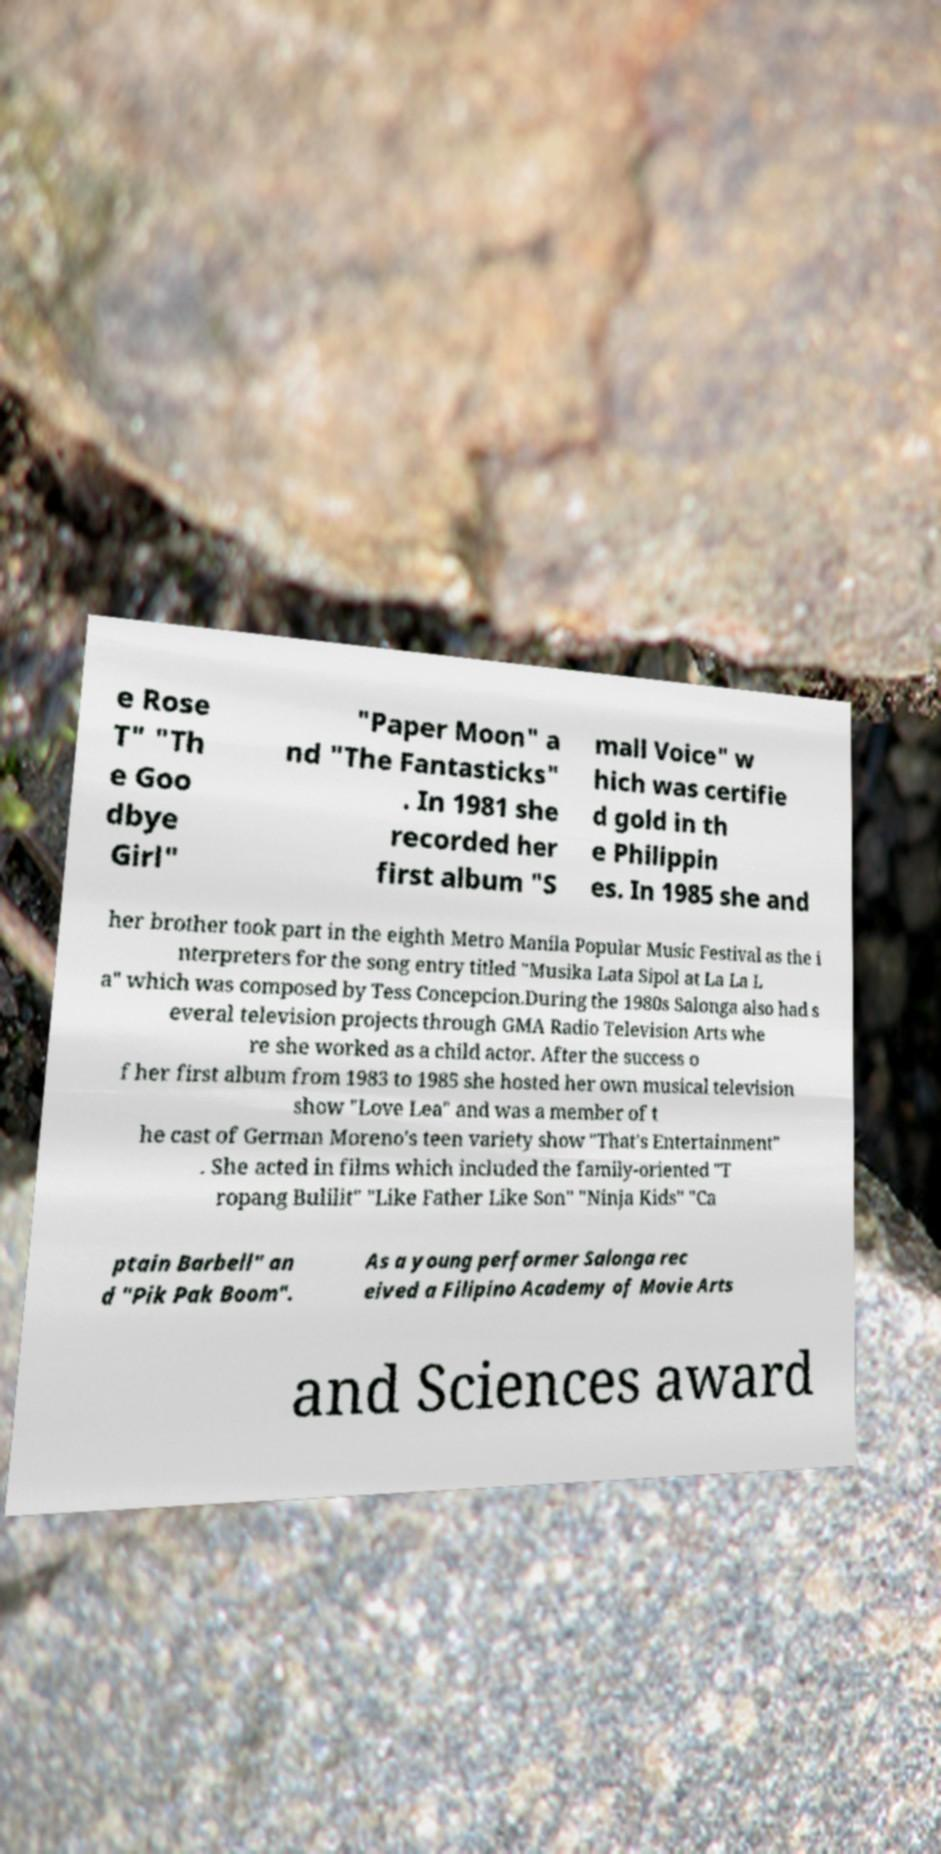Please read and relay the text visible in this image. What does it say? e Rose T" "Th e Goo dbye Girl" "Paper Moon" a nd "The Fantasticks" . In 1981 she recorded her first album "S mall Voice" w hich was certifie d gold in th e Philippin es. In 1985 she and her brother took part in the eighth Metro Manila Popular Music Festival as the i nterpreters for the song entry titled "Musika Lata Sipol at La La L a" which was composed by Tess Concepcion.During the 1980s Salonga also had s everal television projects through GMA Radio Television Arts whe re she worked as a child actor. After the success o f her first album from 1983 to 1985 she hosted her own musical television show "Love Lea" and was a member of t he cast of German Moreno's teen variety show "That's Entertainment" . She acted in films which included the family-oriented "T ropang Bulilit" "Like Father Like Son" "Ninja Kids" "Ca ptain Barbell" an d "Pik Pak Boom". As a young performer Salonga rec eived a Filipino Academy of Movie Arts and Sciences award 